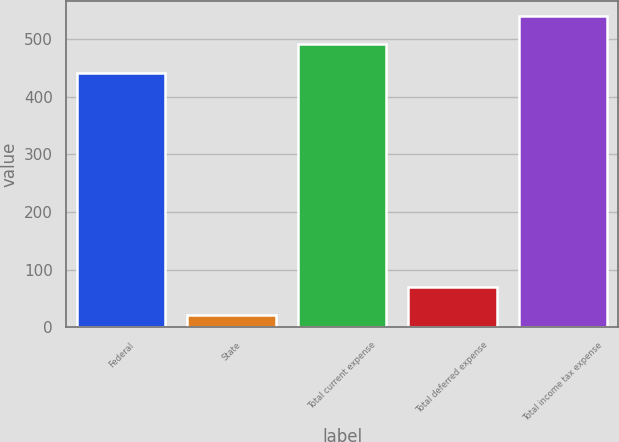Convert chart. <chart><loc_0><loc_0><loc_500><loc_500><bar_chart><fcel>Federal<fcel>State<fcel>Total current expense<fcel>Total deferred expense<fcel>Total income tax expense<nl><fcel>442<fcel>21<fcel>490.9<fcel>69.9<fcel>539.8<nl></chart> 